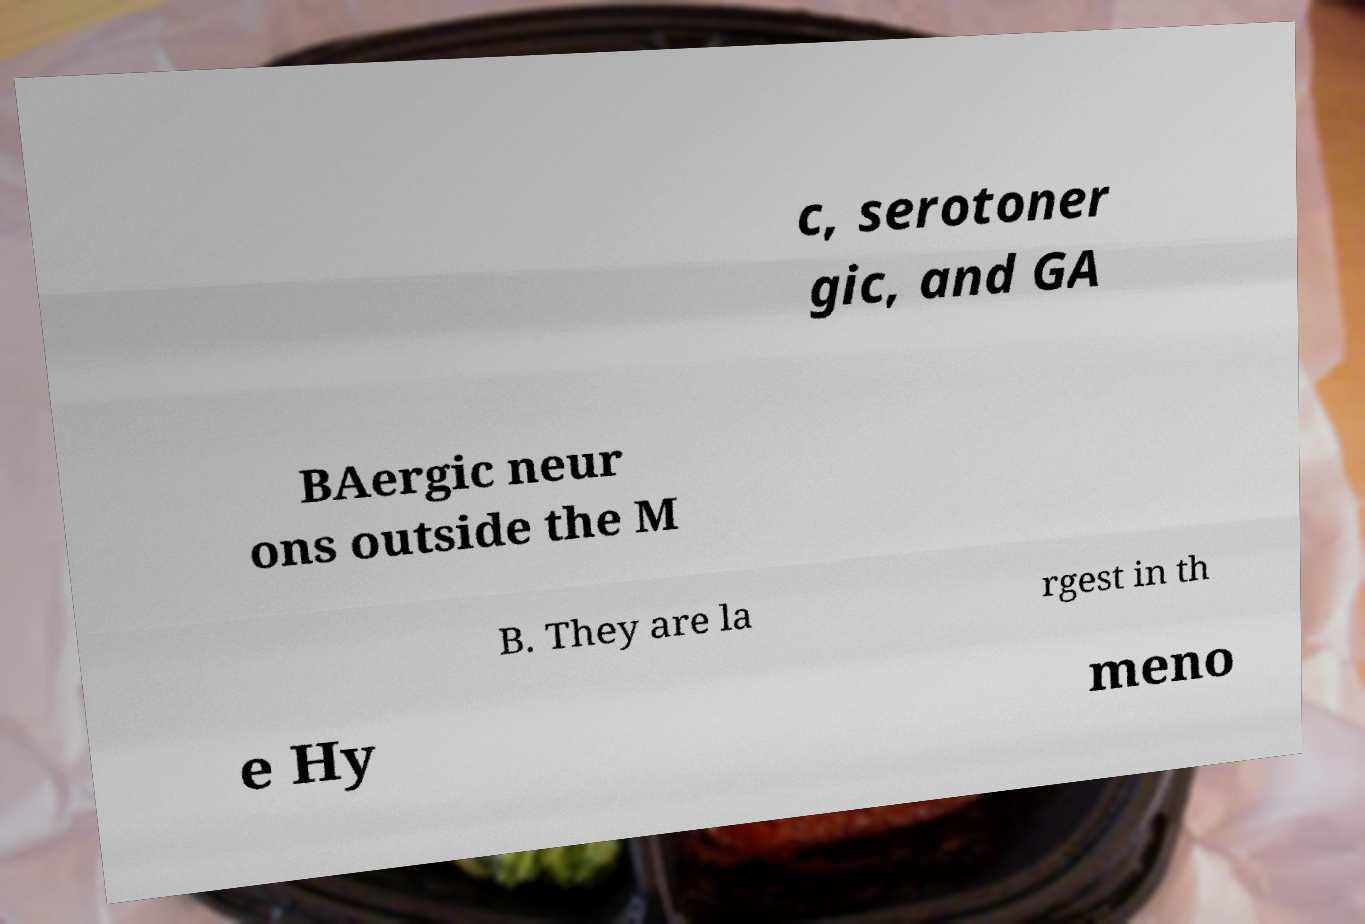What messages or text are displayed in this image? I need them in a readable, typed format. c, serotoner gic, and GA BAergic neur ons outside the M B. They are la rgest in th e Hy meno 